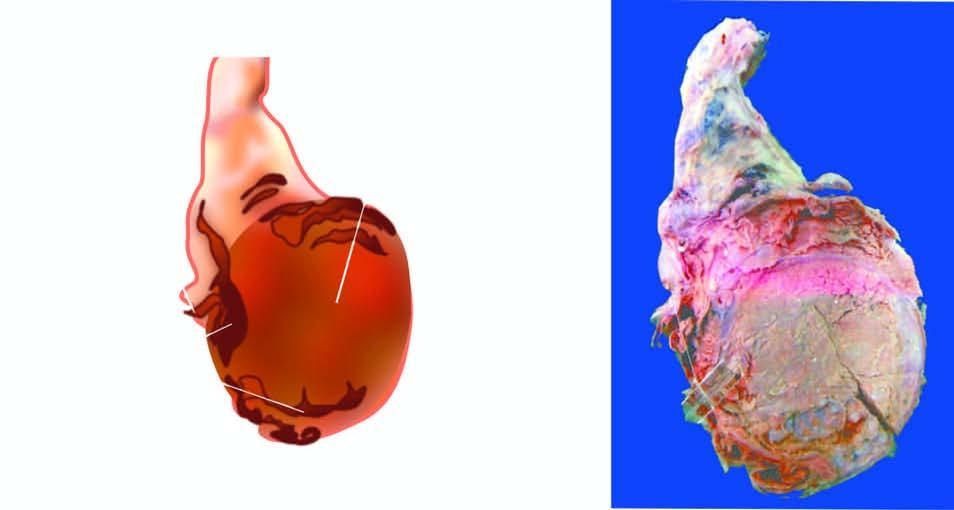does sectioned surface show replacement of the entire testis by variegated mass having grey-white solid areas, cystic areas, honey-combed areas and foci of cartilage and bone?
Answer the question using a single word or phrase. Yes 